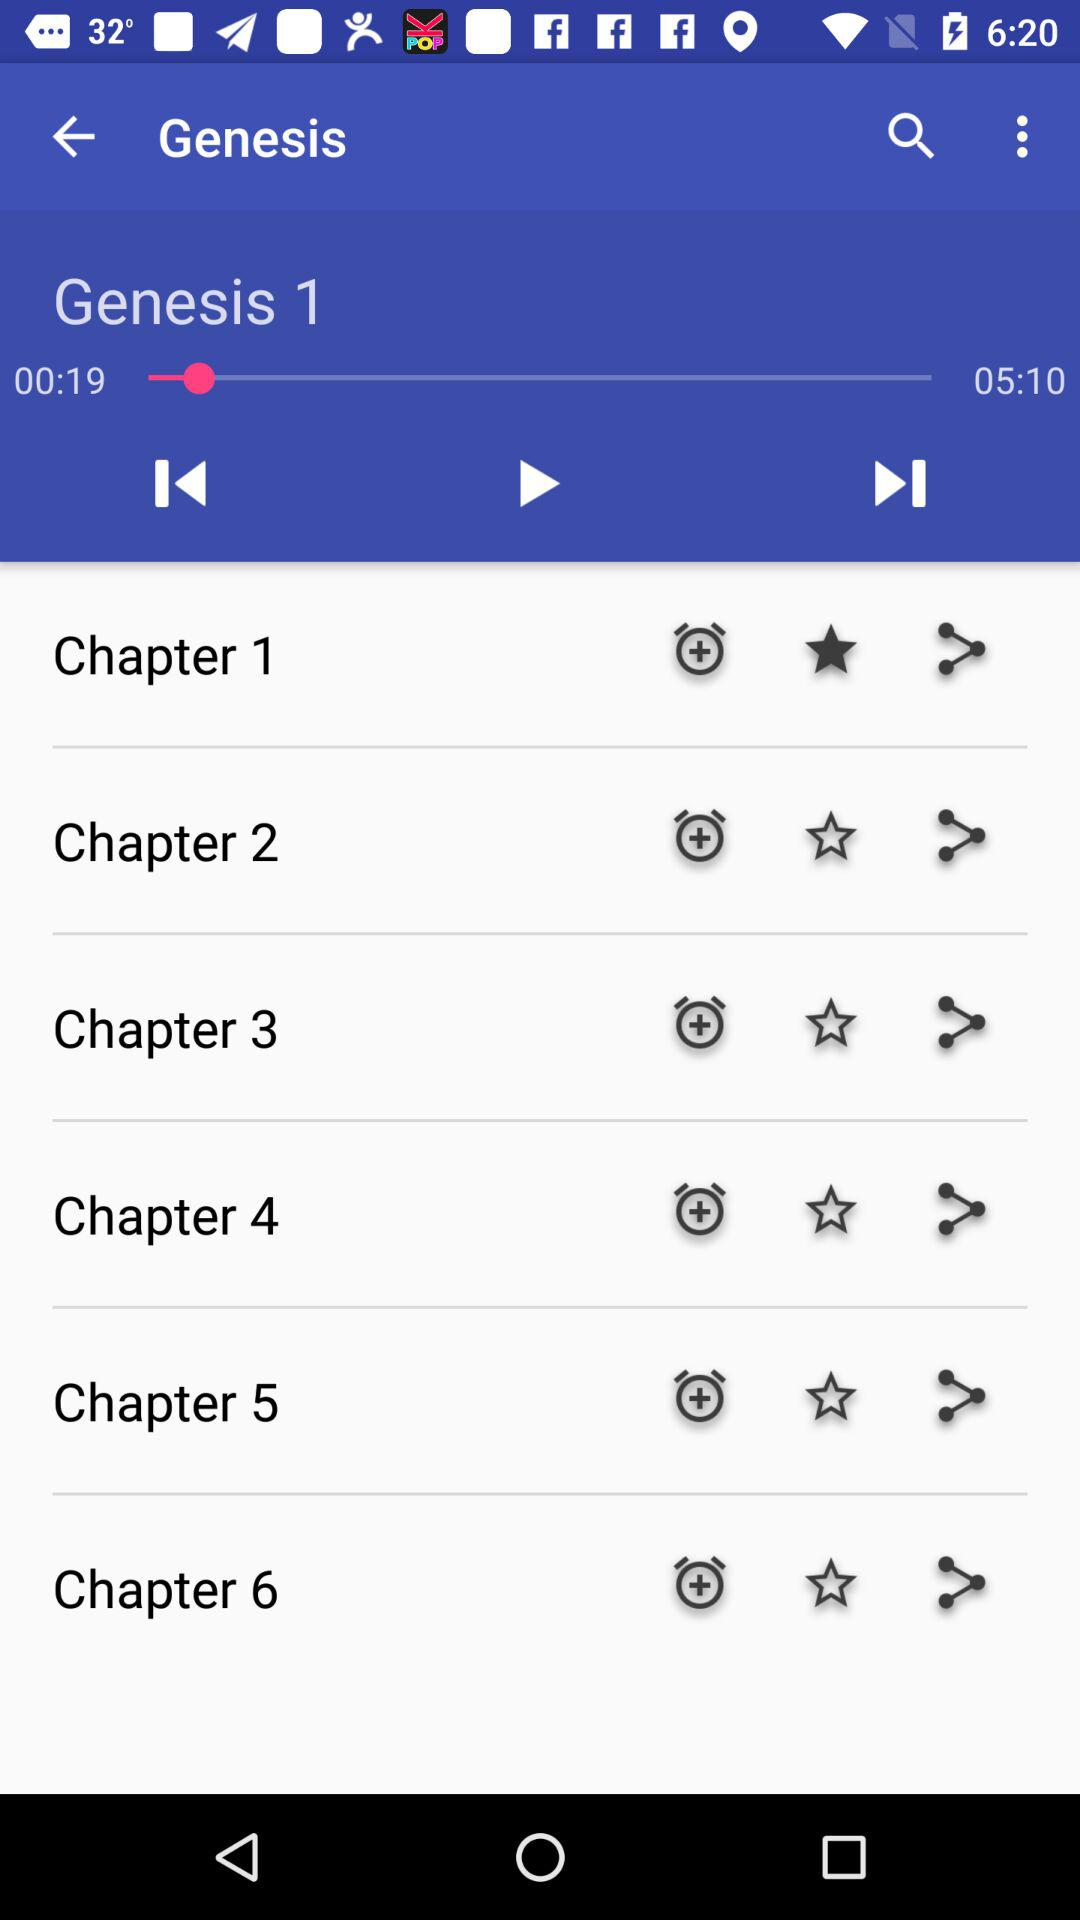What is the duration of "Genesis 1"? The duration is 5 minutes 10 seconds. 